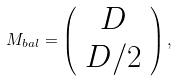<formula> <loc_0><loc_0><loc_500><loc_500>M _ { b a l } = \left ( \begin{array} { c } D \\ D / 2 \end{array} \right ) ,</formula> 